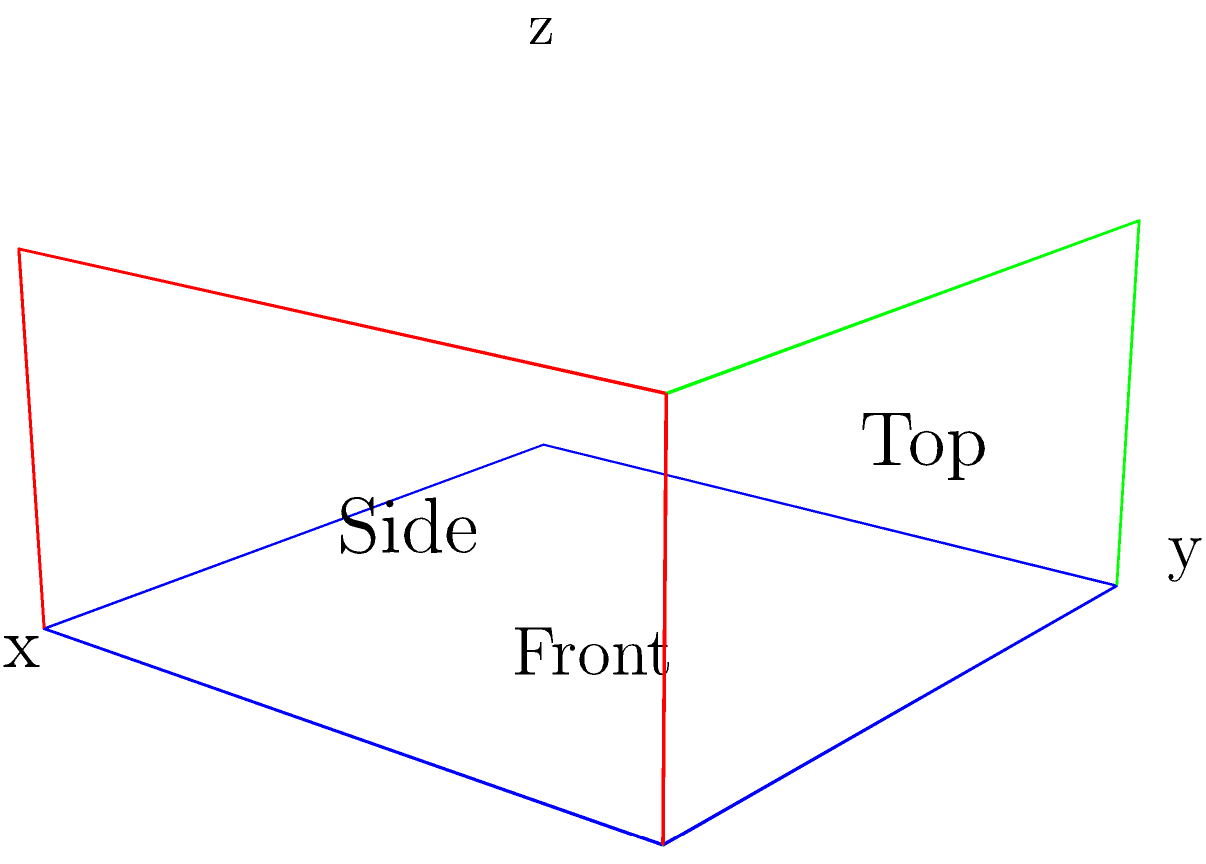Based on the 2D wireframe representations shown in the diagram, which of the following best describes the 3D structure of a responsive website design?

A) A flat, single-layer design
B) A multi-layered, stepped design
C) A cube-like structure with equal dimensions
D) A rectangular prism with varying depths To visualize the 3D structure of the responsive website design from the given 2D wireframes, let's analyze the diagram step-by-step:

1. Front view (blue):
   - Represents the main layout of the website as seen by the user
   - Shows a rectangular shape, indicating the overall width and height of the design

2. Side view (red):
   - Illustrates the depth of the design
   - Shows varying depths, suggesting different layers or sections of the website

3. Top view (green):
   - Provides information about the width and depth of the design
   - Confirms the rectangular shape and varying depths seen in the side view

4. Combining the views:
   - The front view establishes the primary x-y plane
   - The side view shows how the design extends along the z-axis
   - The top view corroborates the x-z dimensions

5. Responsive design implications:
   - The varying depths suggest different components or sections that can be adjusted for different screen sizes
   - The rectangular prism structure allows for flexible rearrangement of elements in responsive layouts

6. Django and FloppyForms context:
   - This structure is compatible with Django's template system, where different blocks can represent the varying depths
   - FloppyForms can be used to create form elements that fit within these different sections

Considering all these factors, the 3D structure that best describes this responsive website design is a rectangular prism with varying depths. This structure allows for a flexible, multi-layered design that can adapt to different screen sizes and orientations, which is crucial for responsive web design.
Answer: D) A rectangular prism with varying depths 